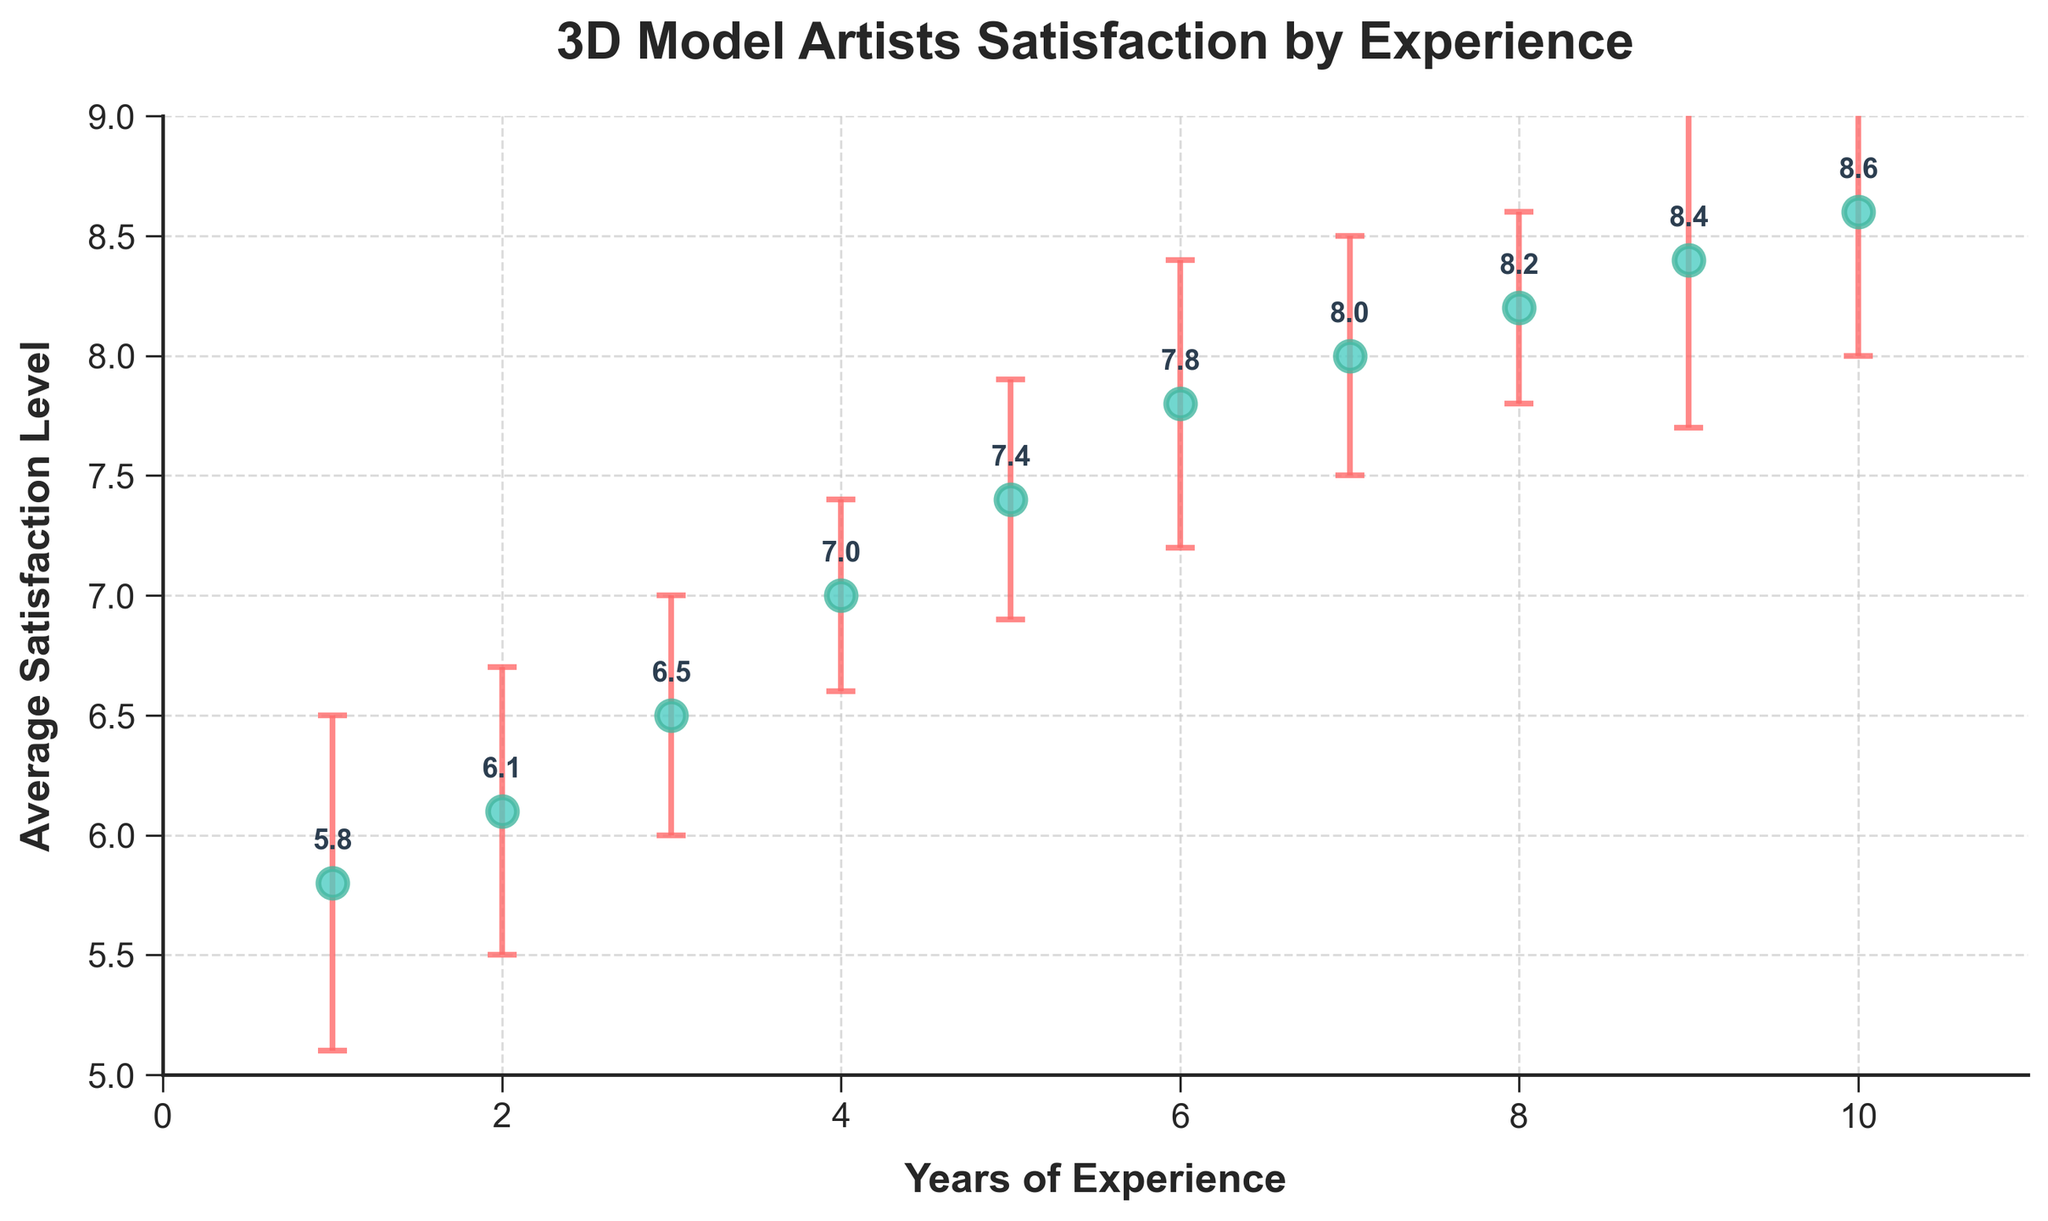What's the title of the figure? The title is displayed at the top of the figure in a larger, bold font. It reads "3D Model Artists Satisfaction by Experience."
Answer: 3D Model Artists Satisfaction by Experience What are the units on the x-axis? The x-axis is labeled as "Years of Experience," which indicates that the units are years.
Answer: Years of Experience What is the average satisfaction level for 3D model artists with 5 years of experience? The plot shows data points with average satisfaction levels annotated. The point at 5 years of experience is labeled as 7.4.
Answer: 7.4 Which year of experience has the highest average satisfaction level and what is it? By examining the plot, the highest point occurs at 10 years of experience, and the annotated label indicates an average satisfaction level of 8.6.
Answer: 10, 8.6 How does the satisfaction level change from the first year to the second year? The satisfaction level at 1 year is 5.8, and at 2 years it is 6.1. Subtracting these values, the increase is 0.3.
Answer: 0.3 What is the range of average satisfaction levels shown in the figure? The lowest average satisfaction level is 5.8 (1 year), and the highest is 8.6 (10 years). The range is the difference between these values: 8.6 - 5.8 = 2.8.
Answer: 2.8 Which range of experience years has the smallest error bars? The error bars represent the standard deviation. Visually, the smallest error bars appear at 4 and 8 years of experience, both with an error range (standard deviation) of ±0.4.
Answer: 4 and 8 What is the difference in average satisfaction levels between artists with 3 years and 7 years of experience? For 3 years, the satisfaction level is 6.5, and for 7 years, it is 8.0. The difference is 8.0 - 6.5 = 1.5.
Answer: 1.5 For how many years of experience does the average satisfaction level exceed 8? By observing the annotated data points, the average satisfaction levels exceed 8 for 7, 8, 9, and 10 years of experience. This totals to 4 years.
Answer: 4 Which year of experience has the largest standard deviation and what is it? The error bars represent the standard deviation. The largest error bar appears at 9 years of experience with a standard deviation of ±0.7.
Answer: 9, 0.7 